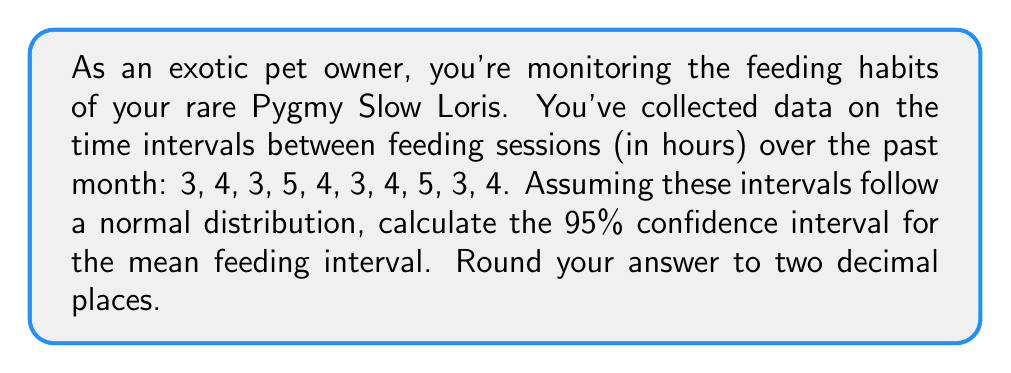Show me your answer to this math problem. To calculate the 95% confidence interval for the mean feeding interval, we'll follow these steps:

1. Calculate the sample mean ($\bar{x}$):
   $$\bar{x} = \frac{3 + 4 + 3 + 5 + 4 + 3 + 4 + 5 + 3 + 4}{10} = 3.8$$

2. Calculate the sample standard deviation ($s$):
   $$s = \sqrt{\frac{\sum(x_i - \bar{x})^2}{n-1}}$$
   $$s = \sqrt{\frac{(3-3.8)^2 + (4-3.8)^2 + ... + (4-3.8)^2}{9}} \approx 0.7888$$

3. Determine the t-value for a 95% confidence interval with 9 degrees of freedom (n-1):
   $t_{0.025, 9} = 2.262$ (from t-distribution table)

4. Calculate the margin of error:
   $$\text{Margin of Error} = t_{0.025, 9} \cdot \frac{s}{\sqrt{n}} = 2.262 \cdot \frac{0.7888}{\sqrt{10}} \approx 0.5636$$

5. Calculate the confidence interval:
   $$\text{CI} = \bar{x} \pm \text{Margin of Error}$$
   $$\text{CI} = 3.8 \pm 0.5636$$
   $$\text{CI} = [3.2364, 4.3636]$$

6. Round to two decimal places:
   $$\text{CI} = [3.24, 4.36]$$
Answer: [3.24, 4.36] 